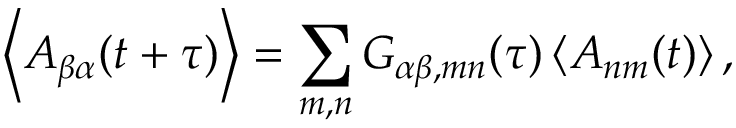<formula> <loc_0><loc_0><loc_500><loc_500>\left \langle A _ { \beta \alpha } ( t + \tau ) \right \rangle = \sum _ { m , n } G _ { \alpha \beta , m n } ( \tau ) \left \langle A _ { n m } ( t ) \right \rangle ,</formula> 